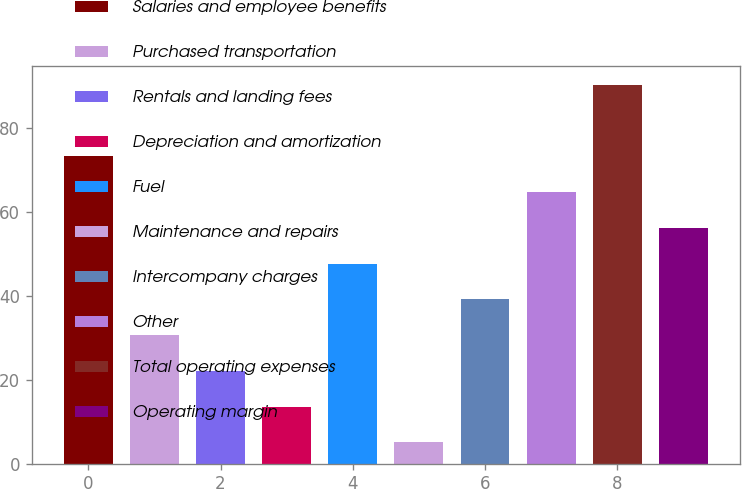Convert chart. <chart><loc_0><loc_0><loc_500><loc_500><bar_chart><fcel>Salaries and employee benefits<fcel>Purchased transportation<fcel>Rentals and landing fees<fcel>Depreciation and amortization<fcel>Fuel<fcel>Maintenance and repairs<fcel>Intercompany charges<fcel>Other<fcel>Total operating expenses<fcel>Operating margin<nl><fcel>73.26<fcel>30.66<fcel>22.14<fcel>13.62<fcel>47.7<fcel>5.1<fcel>39.18<fcel>64.74<fcel>90.3<fcel>56.22<nl></chart> 